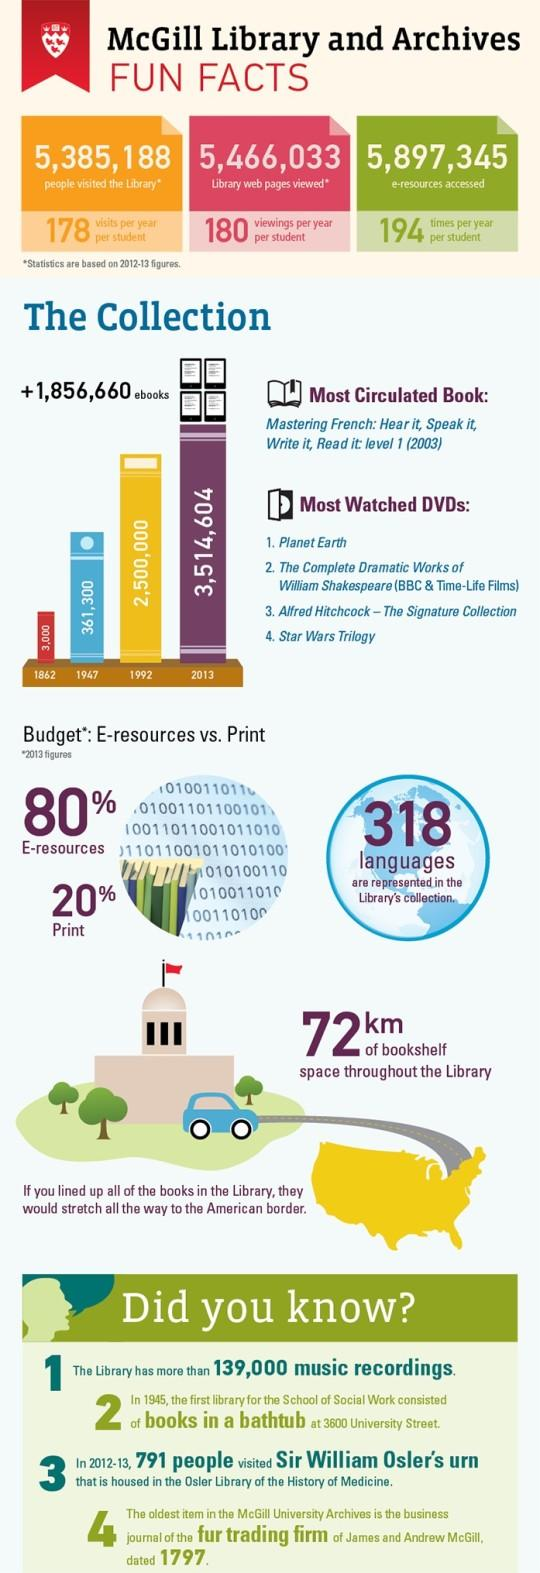Mention a couple of crucial points in this snapshot. In 2013, the McGill Library had a total of 3,514,604 e-book collections available for use. In the 2012-13 academic year, the McGill Library was visited by a total of 5,385,188 people. During the 2012-2013 academic year, a total of 5,897,345 e-resources were accessed at the McGill Library. A report from 2013 indicates that approximately 20% of books available in the McGill Library were printed. 